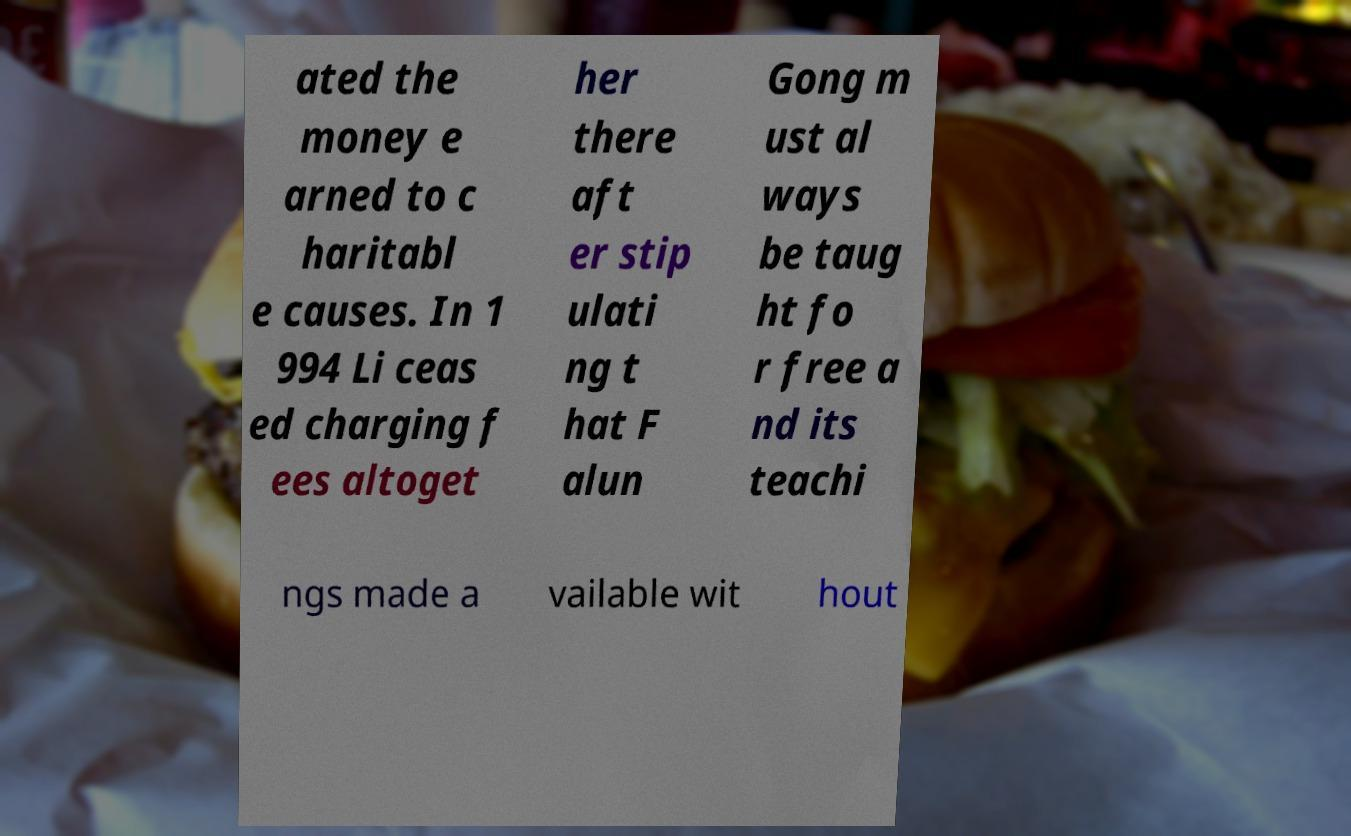Can you read and provide the text displayed in the image?This photo seems to have some interesting text. Can you extract and type it out for me? ated the money e arned to c haritabl e causes. In 1 994 Li ceas ed charging f ees altoget her there aft er stip ulati ng t hat F alun Gong m ust al ways be taug ht fo r free a nd its teachi ngs made a vailable wit hout 